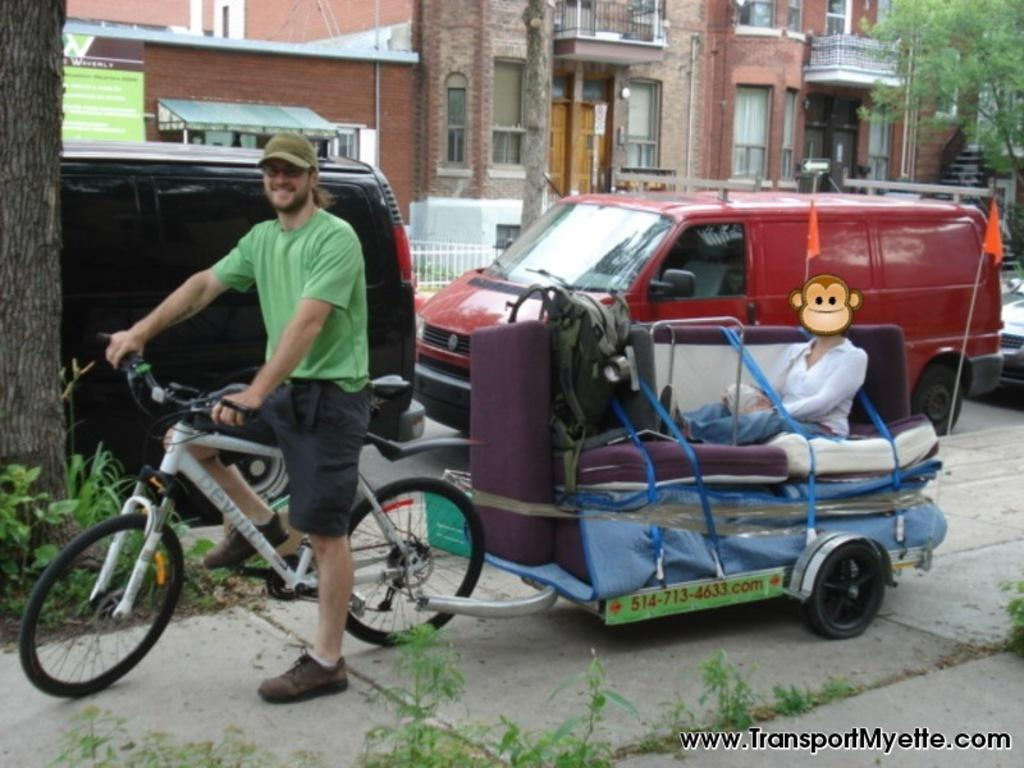What is the man in the image doing? The man is riding a bicycle in the image. What is attached to the bicycle? A cart is attached to the bicycle. What can be seen on the road in the image? There are parked vehicles on the road in the image. What structure is visible in the image? There is a building visible in the image. What type of vegetation is present in the image? There is a tree in the image. What type of cabbage is being used as a fang in the image? There is no cabbage or fang present in the image; it features a man riding a bicycle with a cart attached. 